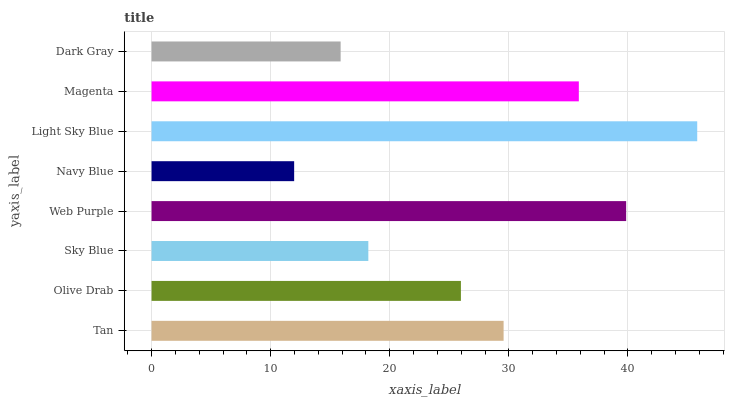Is Navy Blue the minimum?
Answer yes or no. Yes. Is Light Sky Blue the maximum?
Answer yes or no. Yes. Is Olive Drab the minimum?
Answer yes or no. No. Is Olive Drab the maximum?
Answer yes or no. No. Is Tan greater than Olive Drab?
Answer yes or no. Yes. Is Olive Drab less than Tan?
Answer yes or no. Yes. Is Olive Drab greater than Tan?
Answer yes or no. No. Is Tan less than Olive Drab?
Answer yes or no. No. Is Tan the high median?
Answer yes or no. Yes. Is Olive Drab the low median?
Answer yes or no. Yes. Is Light Sky Blue the high median?
Answer yes or no. No. Is Web Purple the low median?
Answer yes or no. No. 